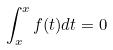<formula> <loc_0><loc_0><loc_500><loc_500>\int _ { x } ^ { x } f ( t ) d t = 0</formula> 